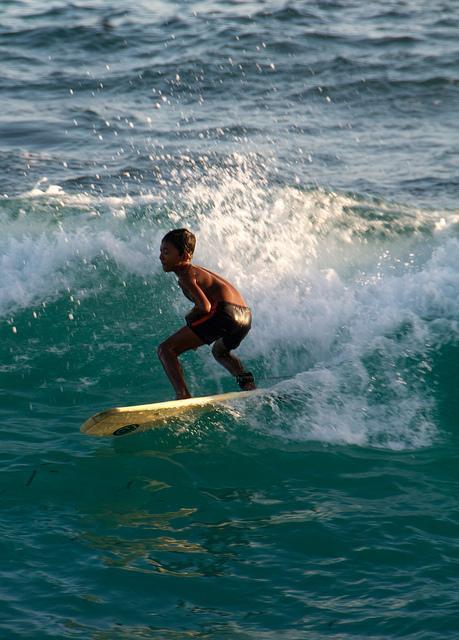How many dogs are in this picture?
Give a very brief answer. 0. 